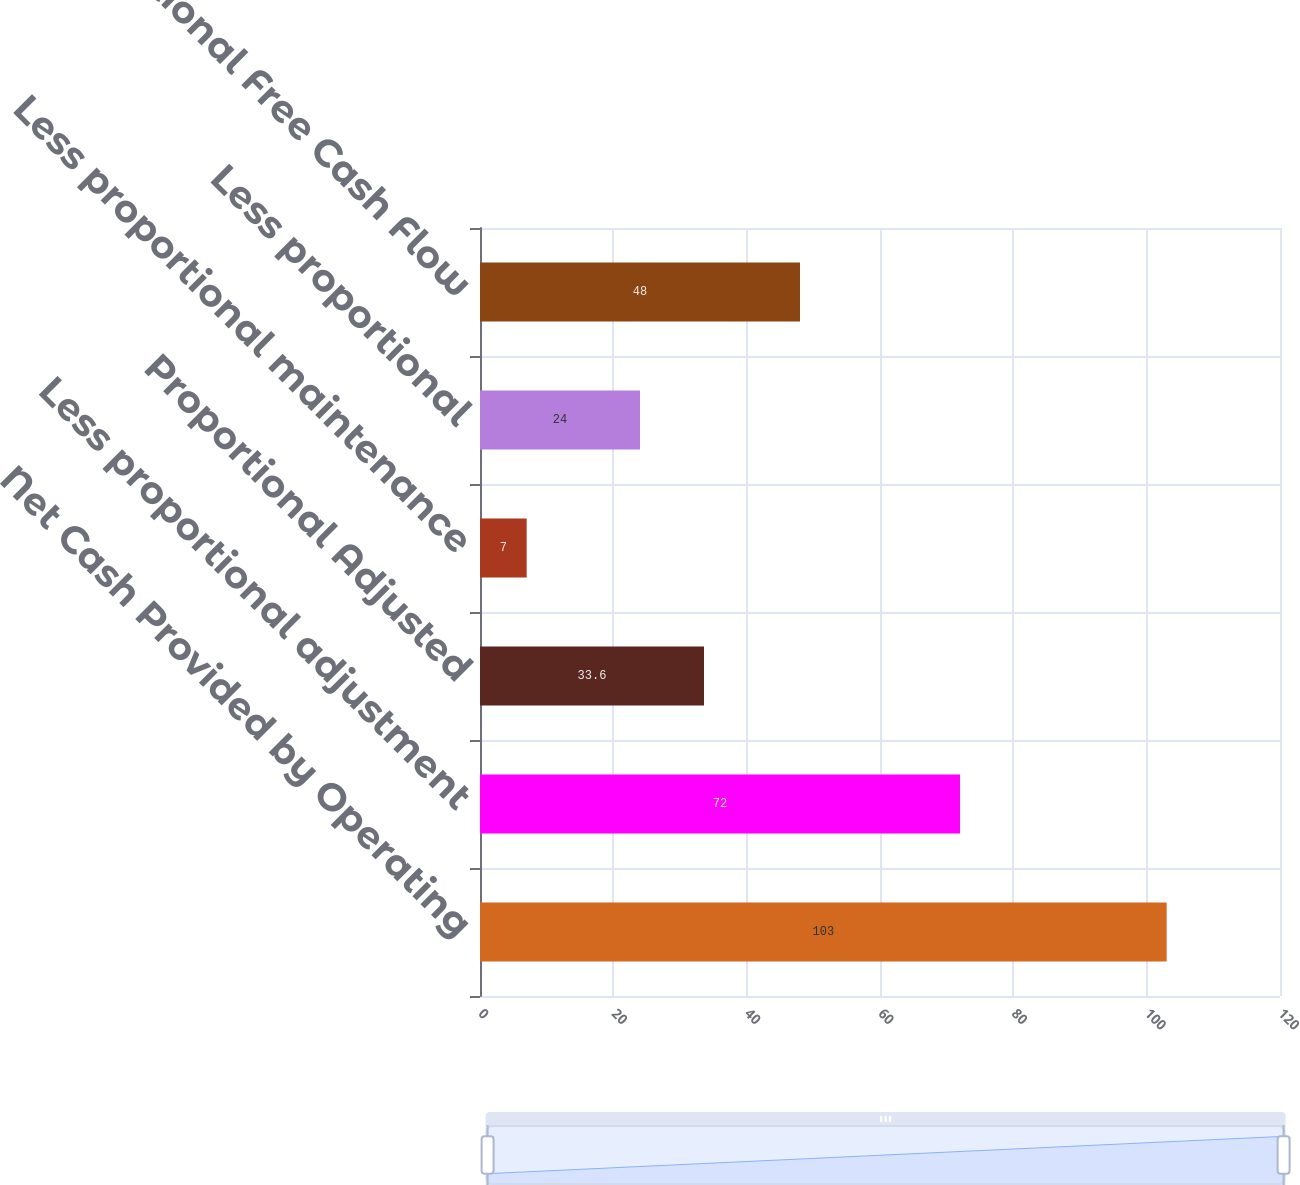<chart> <loc_0><loc_0><loc_500><loc_500><bar_chart><fcel>Net Cash Provided by Operating<fcel>Less proportional adjustment<fcel>Proportional Adjusted<fcel>Less proportional maintenance<fcel>Less proportional<fcel>Proportional Free Cash Flow<nl><fcel>103<fcel>72<fcel>33.6<fcel>7<fcel>24<fcel>48<nl></chart> 